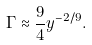Convert formula to latex. <formula><loc_0><loc_0><loc_500><loc_500>\Gamma \approx \frac { 9 } { 4 } y ^ { - 2 / 9 } .</formula> 